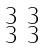<formula> <loc_0><loc_0><loc_500><loc_500>\begin{smallmatrix} 3 & 3 \\ 3 & 3 \end{smallmatrix}</formula> 